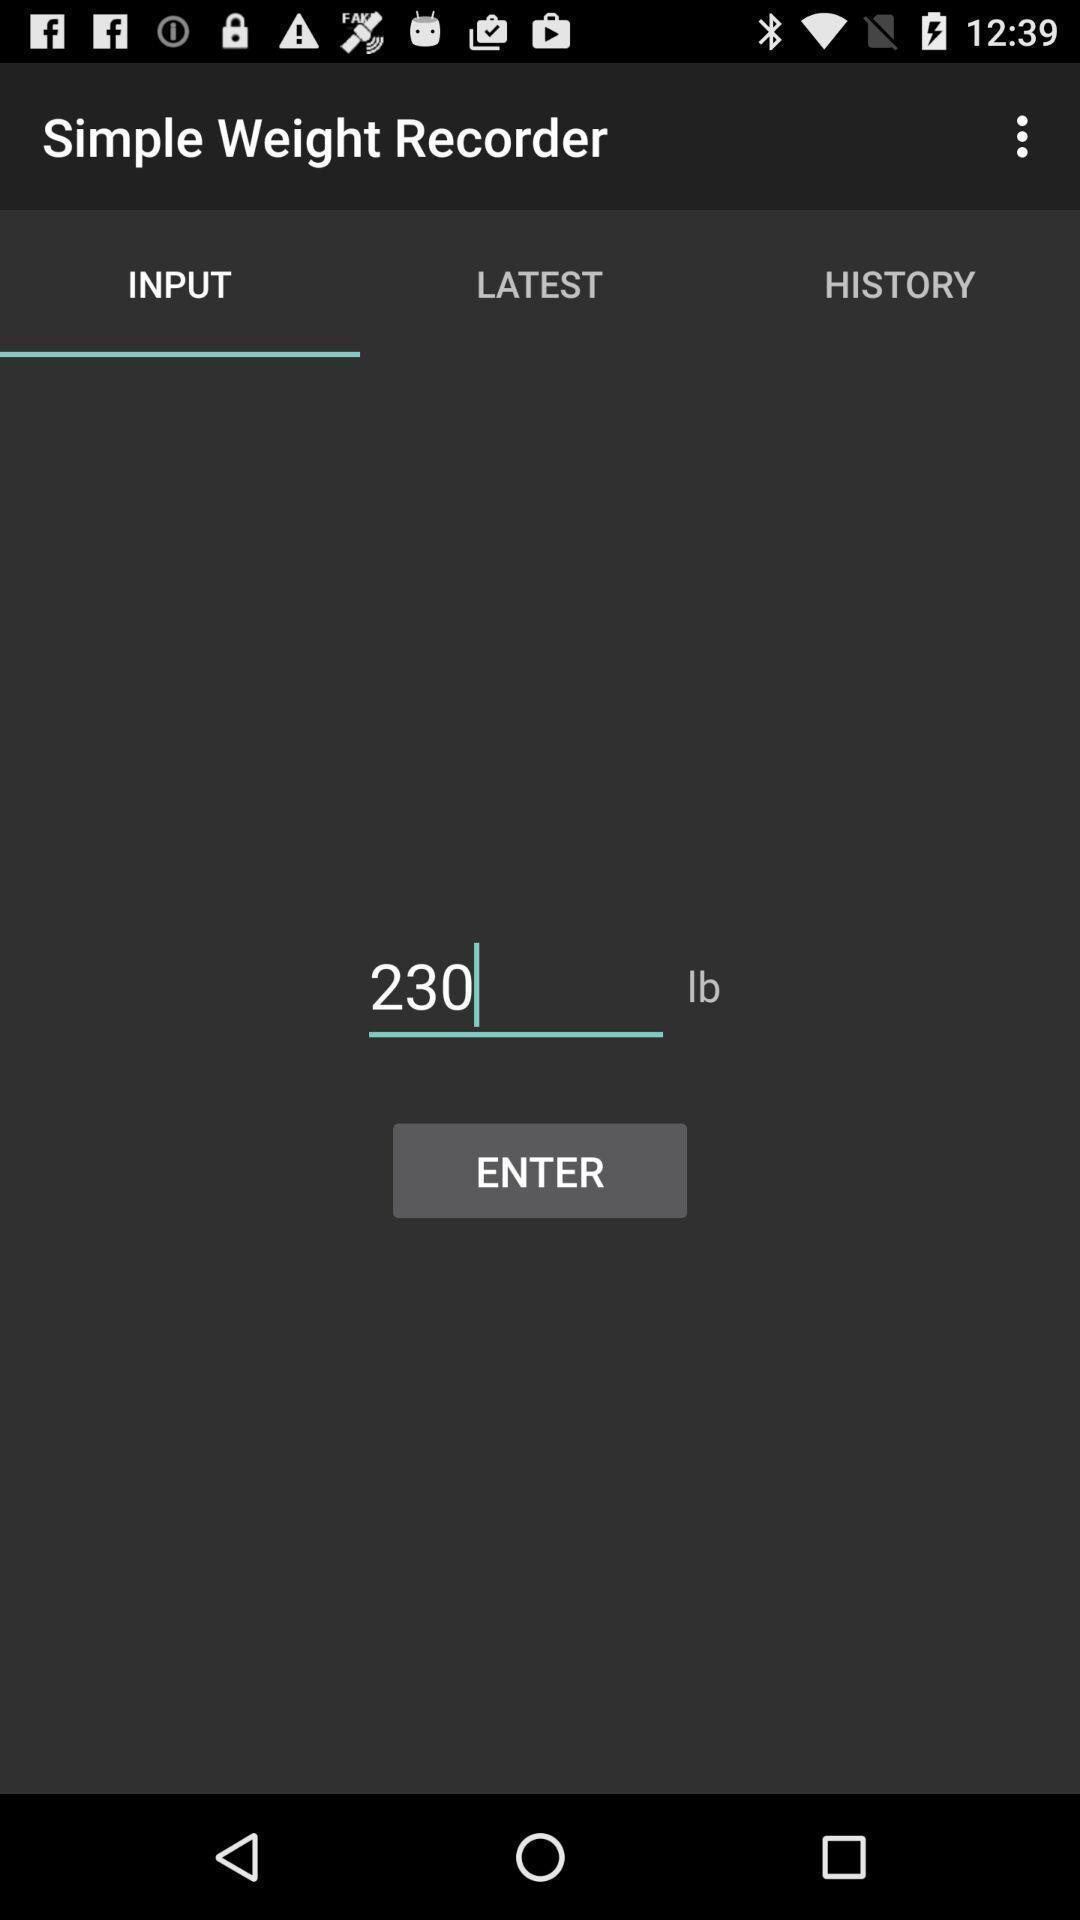Provide a detailed account of this screenshot. Page requesting to enter weight on an app. 